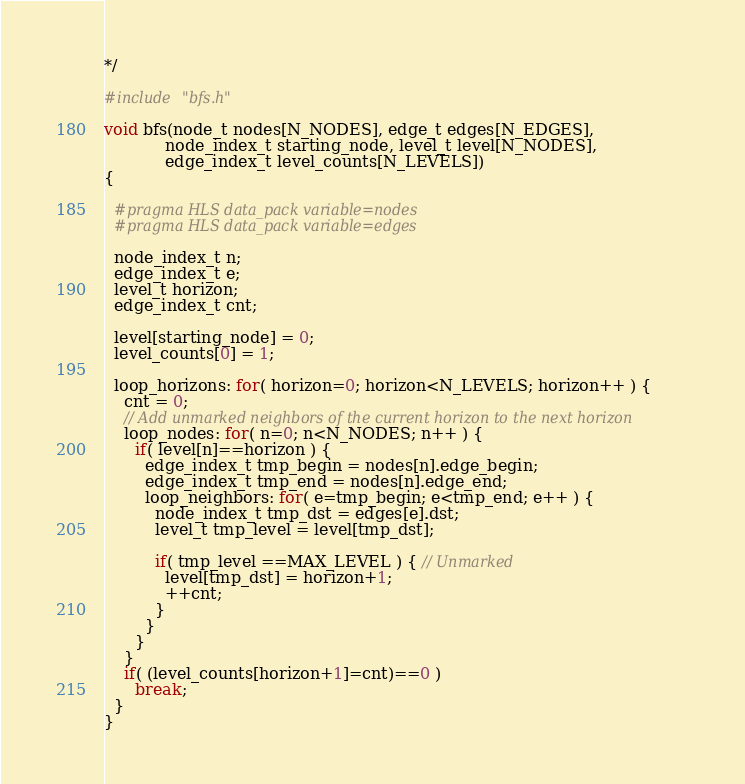Convert code to text. <code><loc_0><loc_0><loc_500><loc_500><_C_>*/

#include "bfs.h"

void bfs(node_t nodes[N_NODES], edge_t edges[N_EDGES],
            node_index_t starting_node, level_t level[N_NODES],
            edge_index_t level_counts[N_LEVELS])
{

  #pragma HLS data_pack variable=nodes
  #pragma HLS data_pack variable=edges
  
  node_index_t n;
  edge_index_t e;
  level_t horizon;
  edge_index_t cnt;

  level[starting_node] = 0;
  level_counts[0] = 1;

  loop_horizons: for( horizon=0; horizon<N_LEVELS; horizon++ ) {
    cnt = 0;
    // Add unmarked neighbors of the current horizon to the next horizon
    loop_nodes: for( n=0; n<N_NODES; n++ ) {
      if( level[n]==horizon ) {
        edge_index_t tmp_begin = nodes[n].edge_begin;
        edge_index_t tmp_end = nodes[n].edge_end;
        loop_neighbors: for( e=tmp_begin; e<tmp_end; e++ ) {
          node_index_t tmp_dst = edges[e].dst;
          level_t tmp_level = level[tmp_dst];

          if( tmp_level ==MAX_LEVEL ) { // Unmarked
            level[tmp_dst] = horizon+1;
            ++cnt;
          }
        }
      }
    }
    if( (level_counts[horizon+1]=cnt)==0 )
      break;
  }
}
</code> 